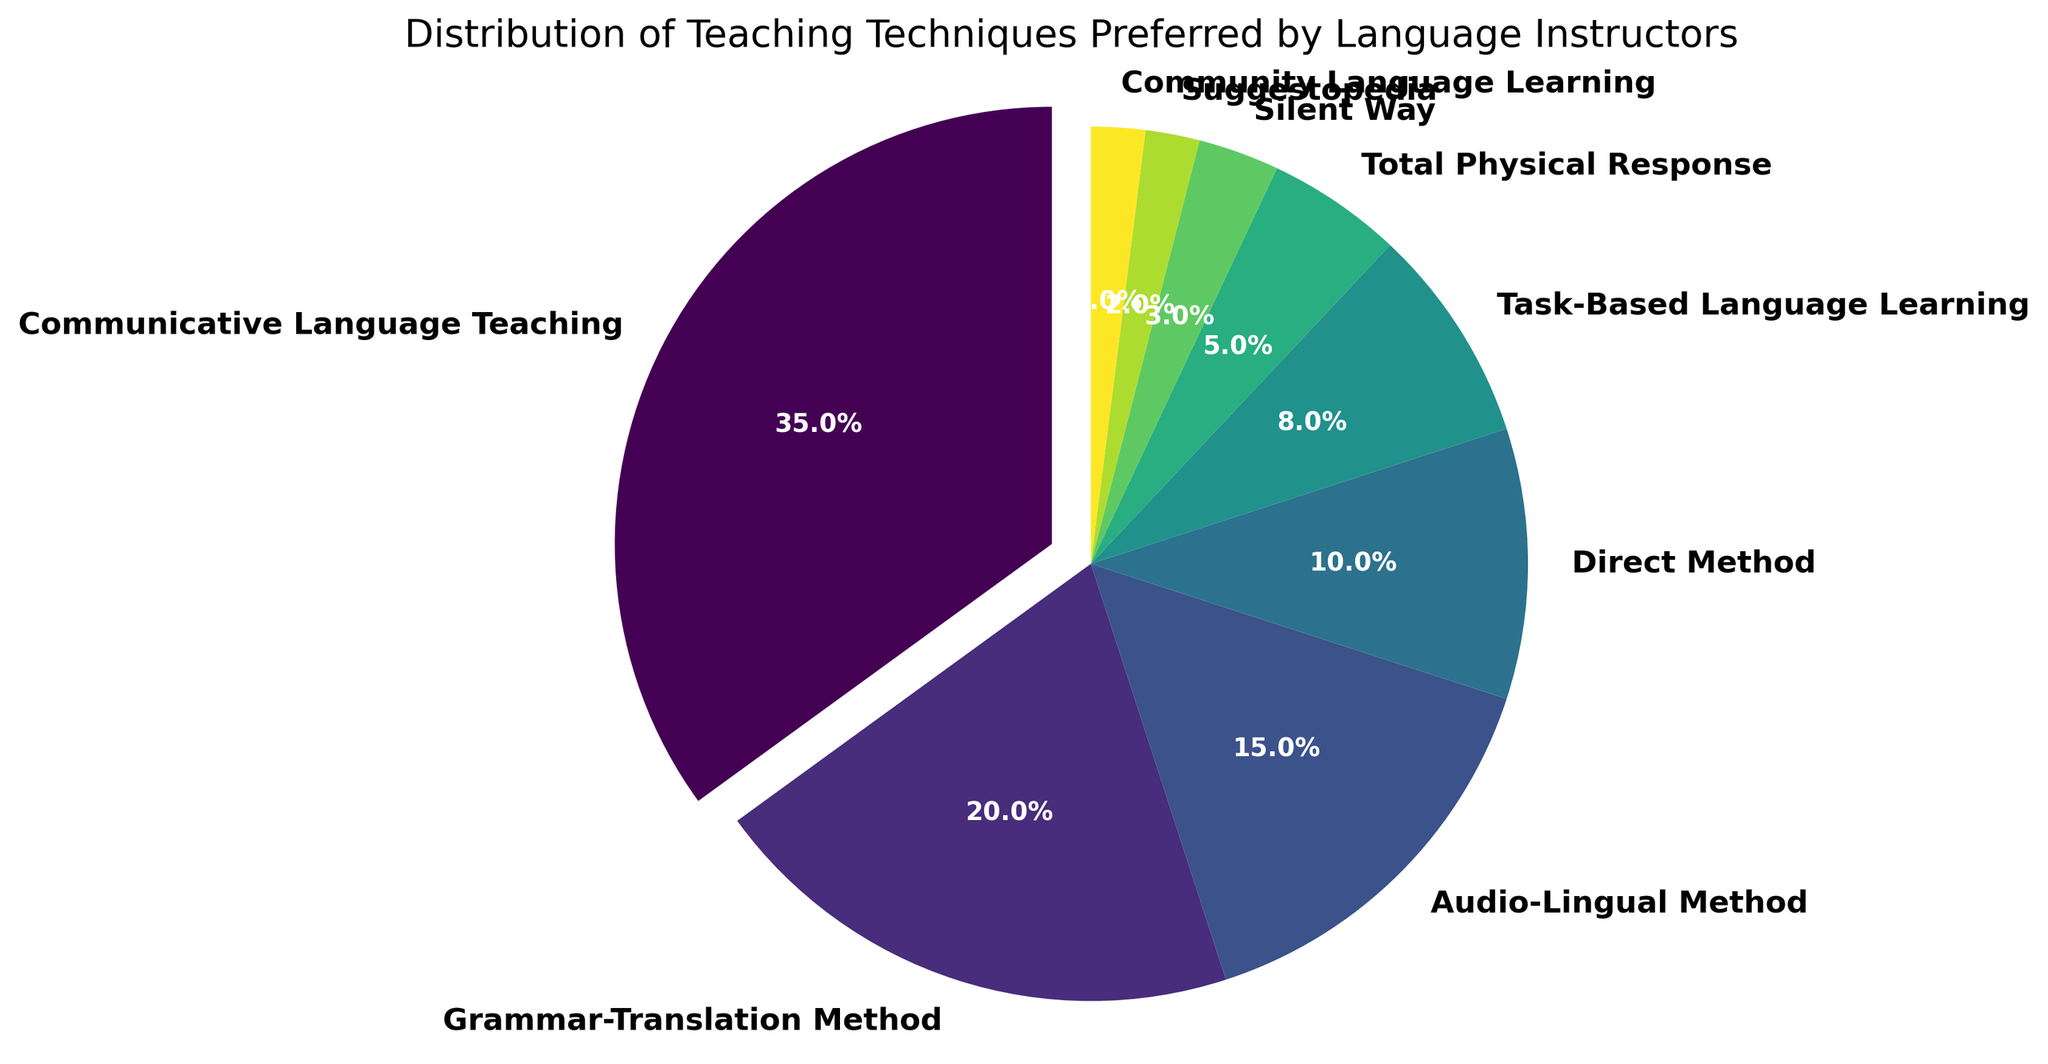Which teaching technique is preferred the most by language instructors? By looking at the pie chart, the largest slice represents the most preferred teaching technique. The label and percentage on this slice indicate it is the Communicative Language Teaching with 35%.
Answer: Communicative Language Teaching What is the combined percentage of instructors who prefer either the Grammar-Translation Method or the Audio-Lingual Method? First, identify the percentages for the Grammar-Translation Method (20%) and the Audio-Lingual Method (15%). Then, sum these percentages: 20% + 15% = 35%.
Answer: 35% Which teaching technique is the least preferred by language instructors? The smallest slice of the pie chart represents the least preferred technique. The label and percentage on this slice indicate it is Community Language Learning with 2%.
Answer: Community Language Learning How much more preferred is the Direct Method compared to Suggestopedia? First, identify the percentages for the Direct Method (10%) and Suggestopedia (2%). Then, find the difference: 10% - 2% = 8%.
Answer: 8% Which two teaching techniques have equal percentages of preference? By looking at the pie chart, the slices labeled Silent Way and Community Language Learning both show the same percentage value of 2%.
Answer: Silent Way and Community Language Learning What percentage of instructors prefer methods other than the Communicative Language Teaching? The total percentage is 100%. Subtract the percentage of instructors who prefer Communicative Language Teaching (35%) from 100%: 100% - 35% = 65%.
Answer: 65% Which segment of the pie chart is the green(ish) color slice representing, assuming the colors vary across the spectrum and knowing that the slices are in order of the given data? The green(ish) color slice likely represents the Audio-Lingual Method, as it is the third technique listed and the colors transition through a gradient.
Answer: Audio-Lingual Method Is the combined preference for Total Physical Response and Silent Way greater than that for the Grammar-Translation Method? First, sum the percentages for Total Physical Response (5%) and Silent Way (3%), which is 5% + 3% = 8%. Compare this with the percentage for Grammar-Translation Method which is 20%. 8% is less than 20%.
Answer: No What is the difference in percentage between the most and least preferred teaching techniques? Identify the percentages for the most preferred (Communicative Language Teaching at 35%) and the least preferred (Community Language Learning at 2%). Calculate the difference: 35% - 2% = 33%.
Answer: 33% Which segment is the first slice exploded out from the pie chart? The exploded (slightly separated) slice is visually noticeable and represents the Communicative Language Teaching, which is also the most preferred technique with 35%.
Answer: Communicative Language Teaching 